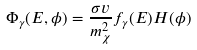<formula> <loc_0><loc_0><loc_500><loc_500>\Phi _ { \gamma } ( E , \phi ) = \frac { \sigma v } { m ^ { 2 } _ { \chi } } f _ { \gamma } ( E ) H ( \phi ) \,</formula> 